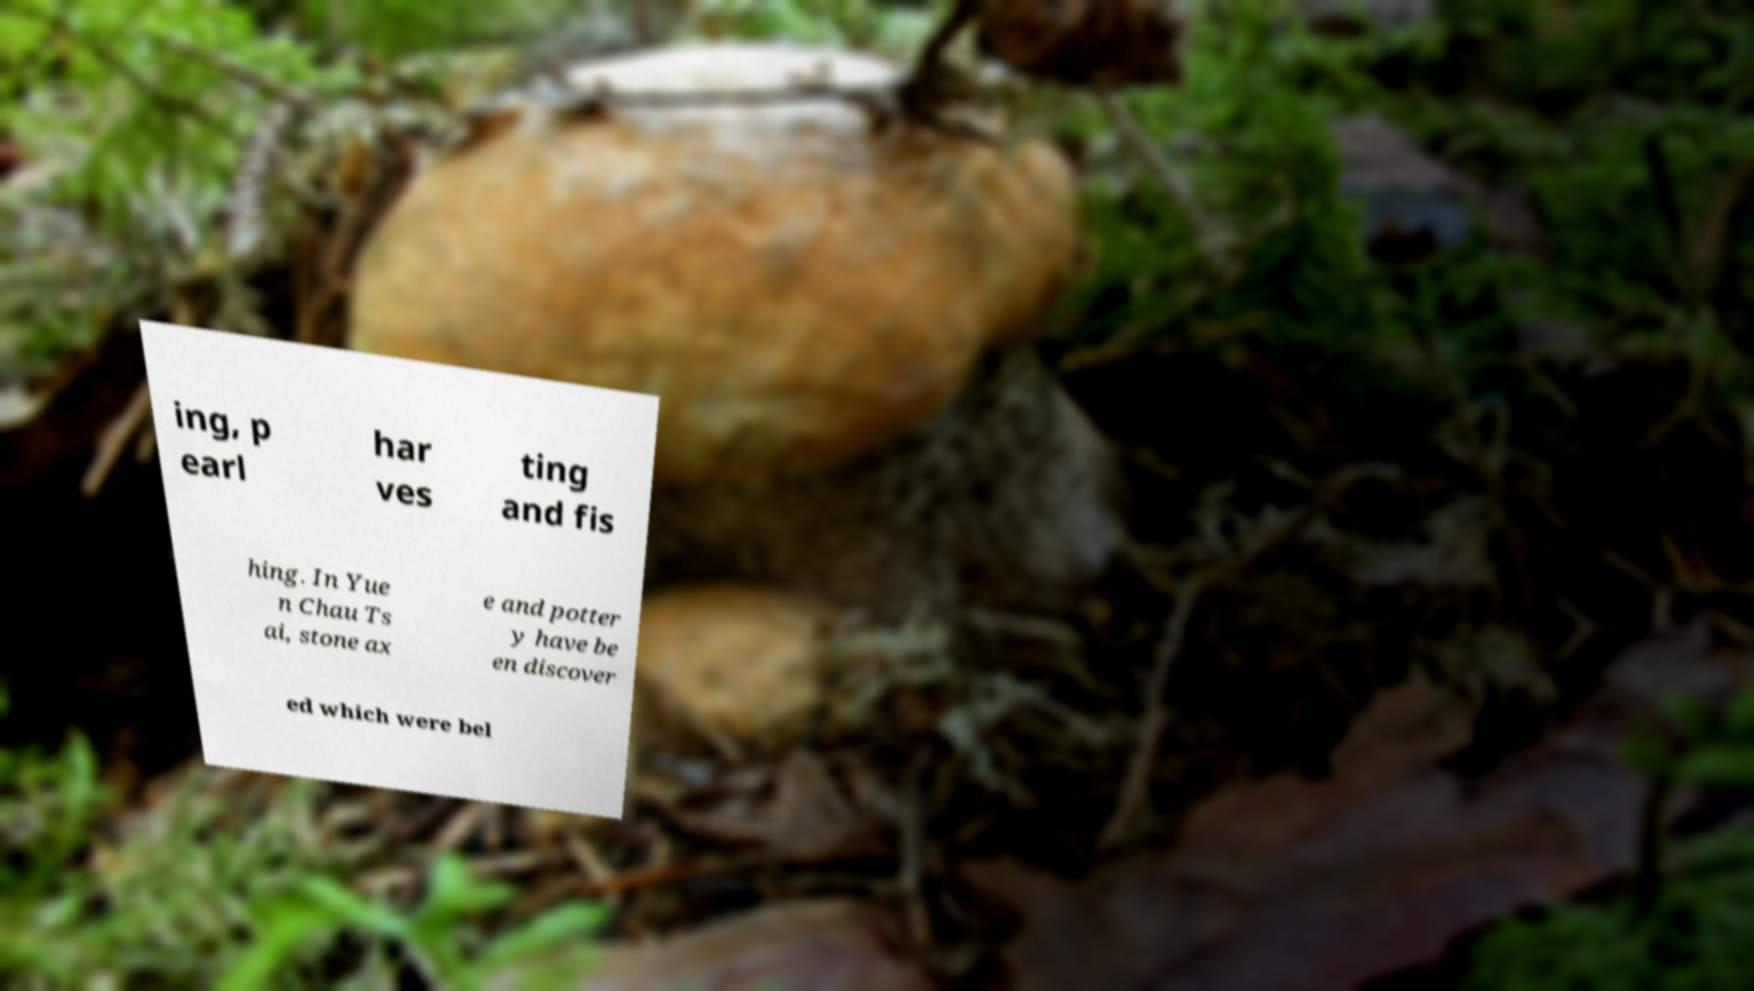Can you read and provide the text displayed in the image?This photo seems to have some interesting text. Can you extract and type it out for me? ing, p earl har ves ting and fis hing. In Yue n Chau Ts ai, stone ax e and potter y have be en discover ed which were bel 